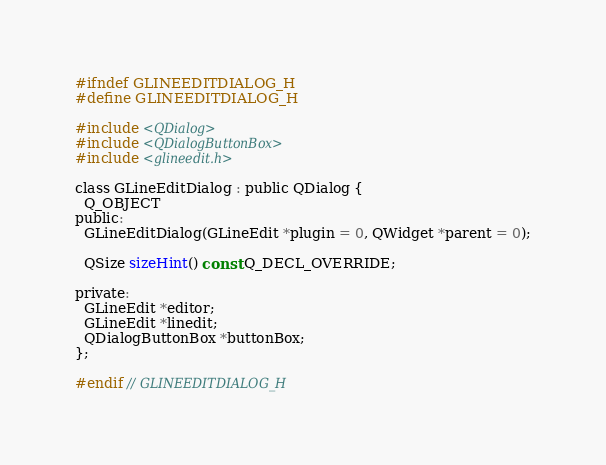<code> <loc_0><loc_0><loc_500><loc_500><_C_>#ifndef GLINEEDITDIALOG_H
#define GLINEEDITDIALOG_H

#include <QDialog>
#include <QDialogButtonBox>
#include <glineedit.h>

class GLineEditDialog : public QDialog {
  Q_OBJECT
public:
  GLineEditDialog(GLineEdit *plugin = 0, QWidget *parent = 0);

  QSize sizeHint() const Q_DECL_OVERRIDE;

private:
  GLineEdit *editor;
  GLineEdit *linedit;
  QDialogButtonBox *buttonBox;
};

#endif // GLINEEDITDIALOG_H
</code> 